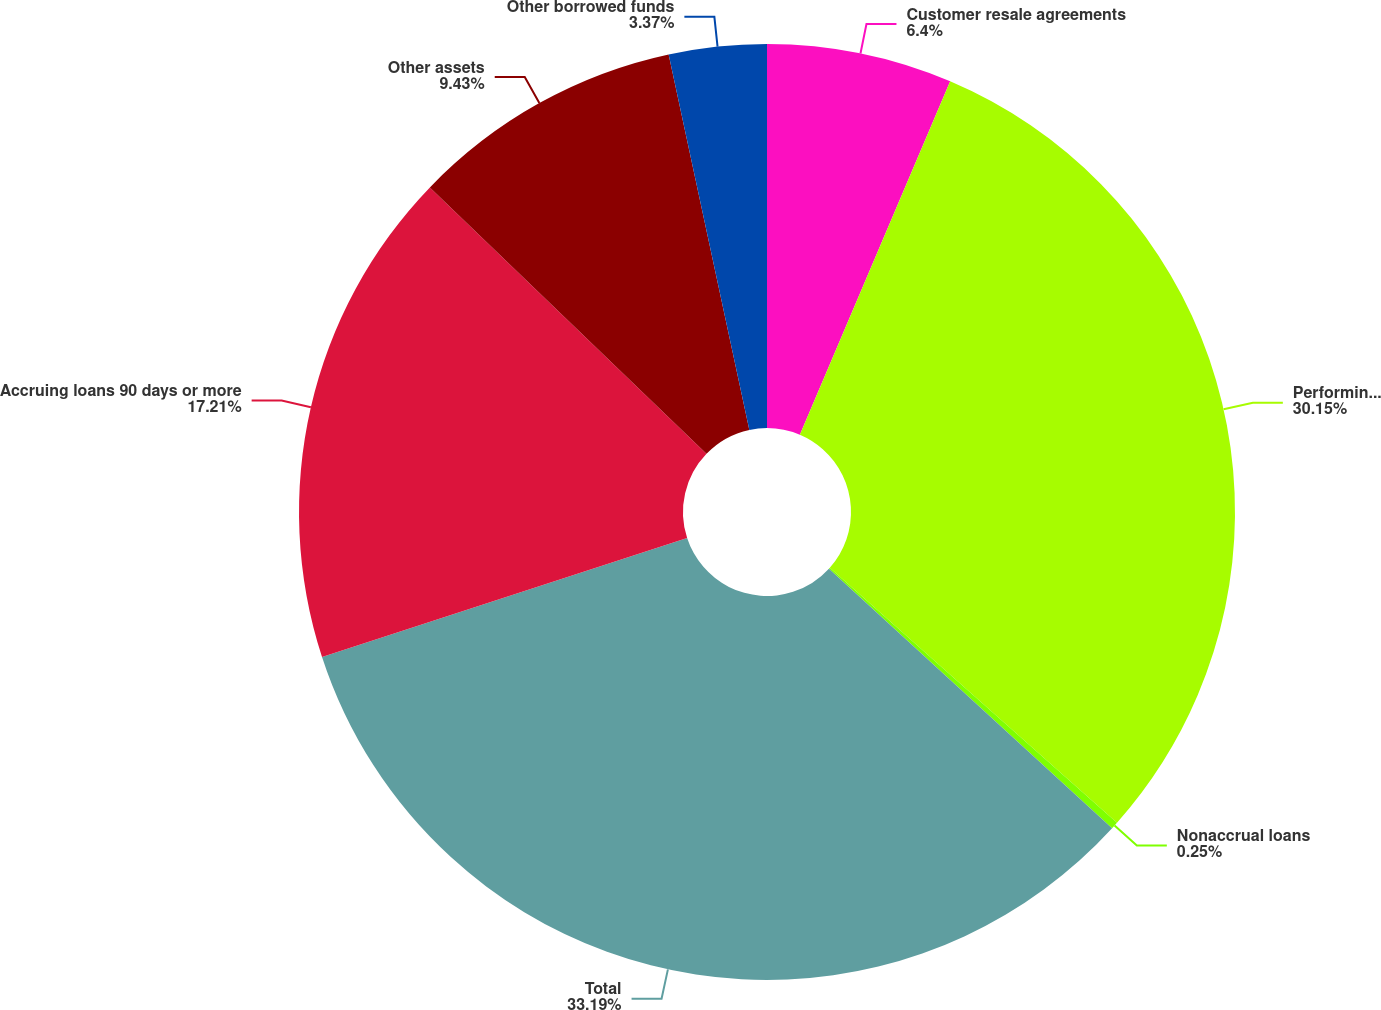<chart> <loc_0><loc_0><loc_500><loc_500><pie_chart><fcel>Customer resale agreements<fcel>Performing loans<fcel>Nonaccrual loans<fcel>Total<fcel>Accruing loans 90 days or more<fcel>Other assets<fcel>Other borrowed funds<nl><fcel>6.4%<fcel>30.15%<fcel>0.25%<fcel>33.18%<fcel>17.21%<fcel>9.43%<fcel>3.37%<nl></chart> 